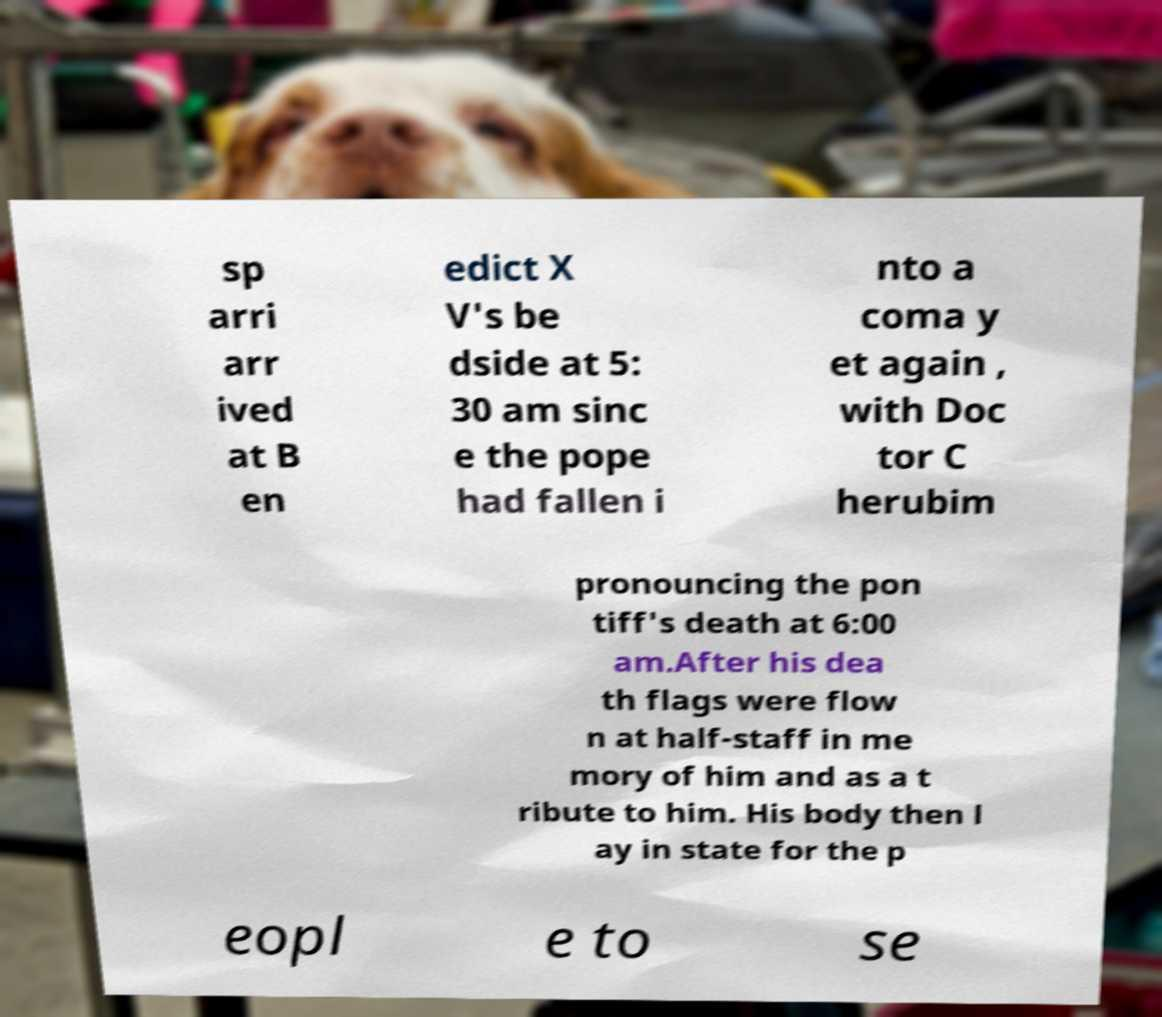There's text embedded in this image that I need extracted. Can you transcribe it verbatim? sp arri arr ived at B en edict X V's be dside at 5: 30 am sinc e the pope had fallen i nto a coma y et again , with Doc tor C herubim pronouncing the pon tiff's death at 6:00 am.After his dea th flags were flow n at half-staff in me mory of him and as a t ribute to him. His body then l ay in state for the p eopl e to se 